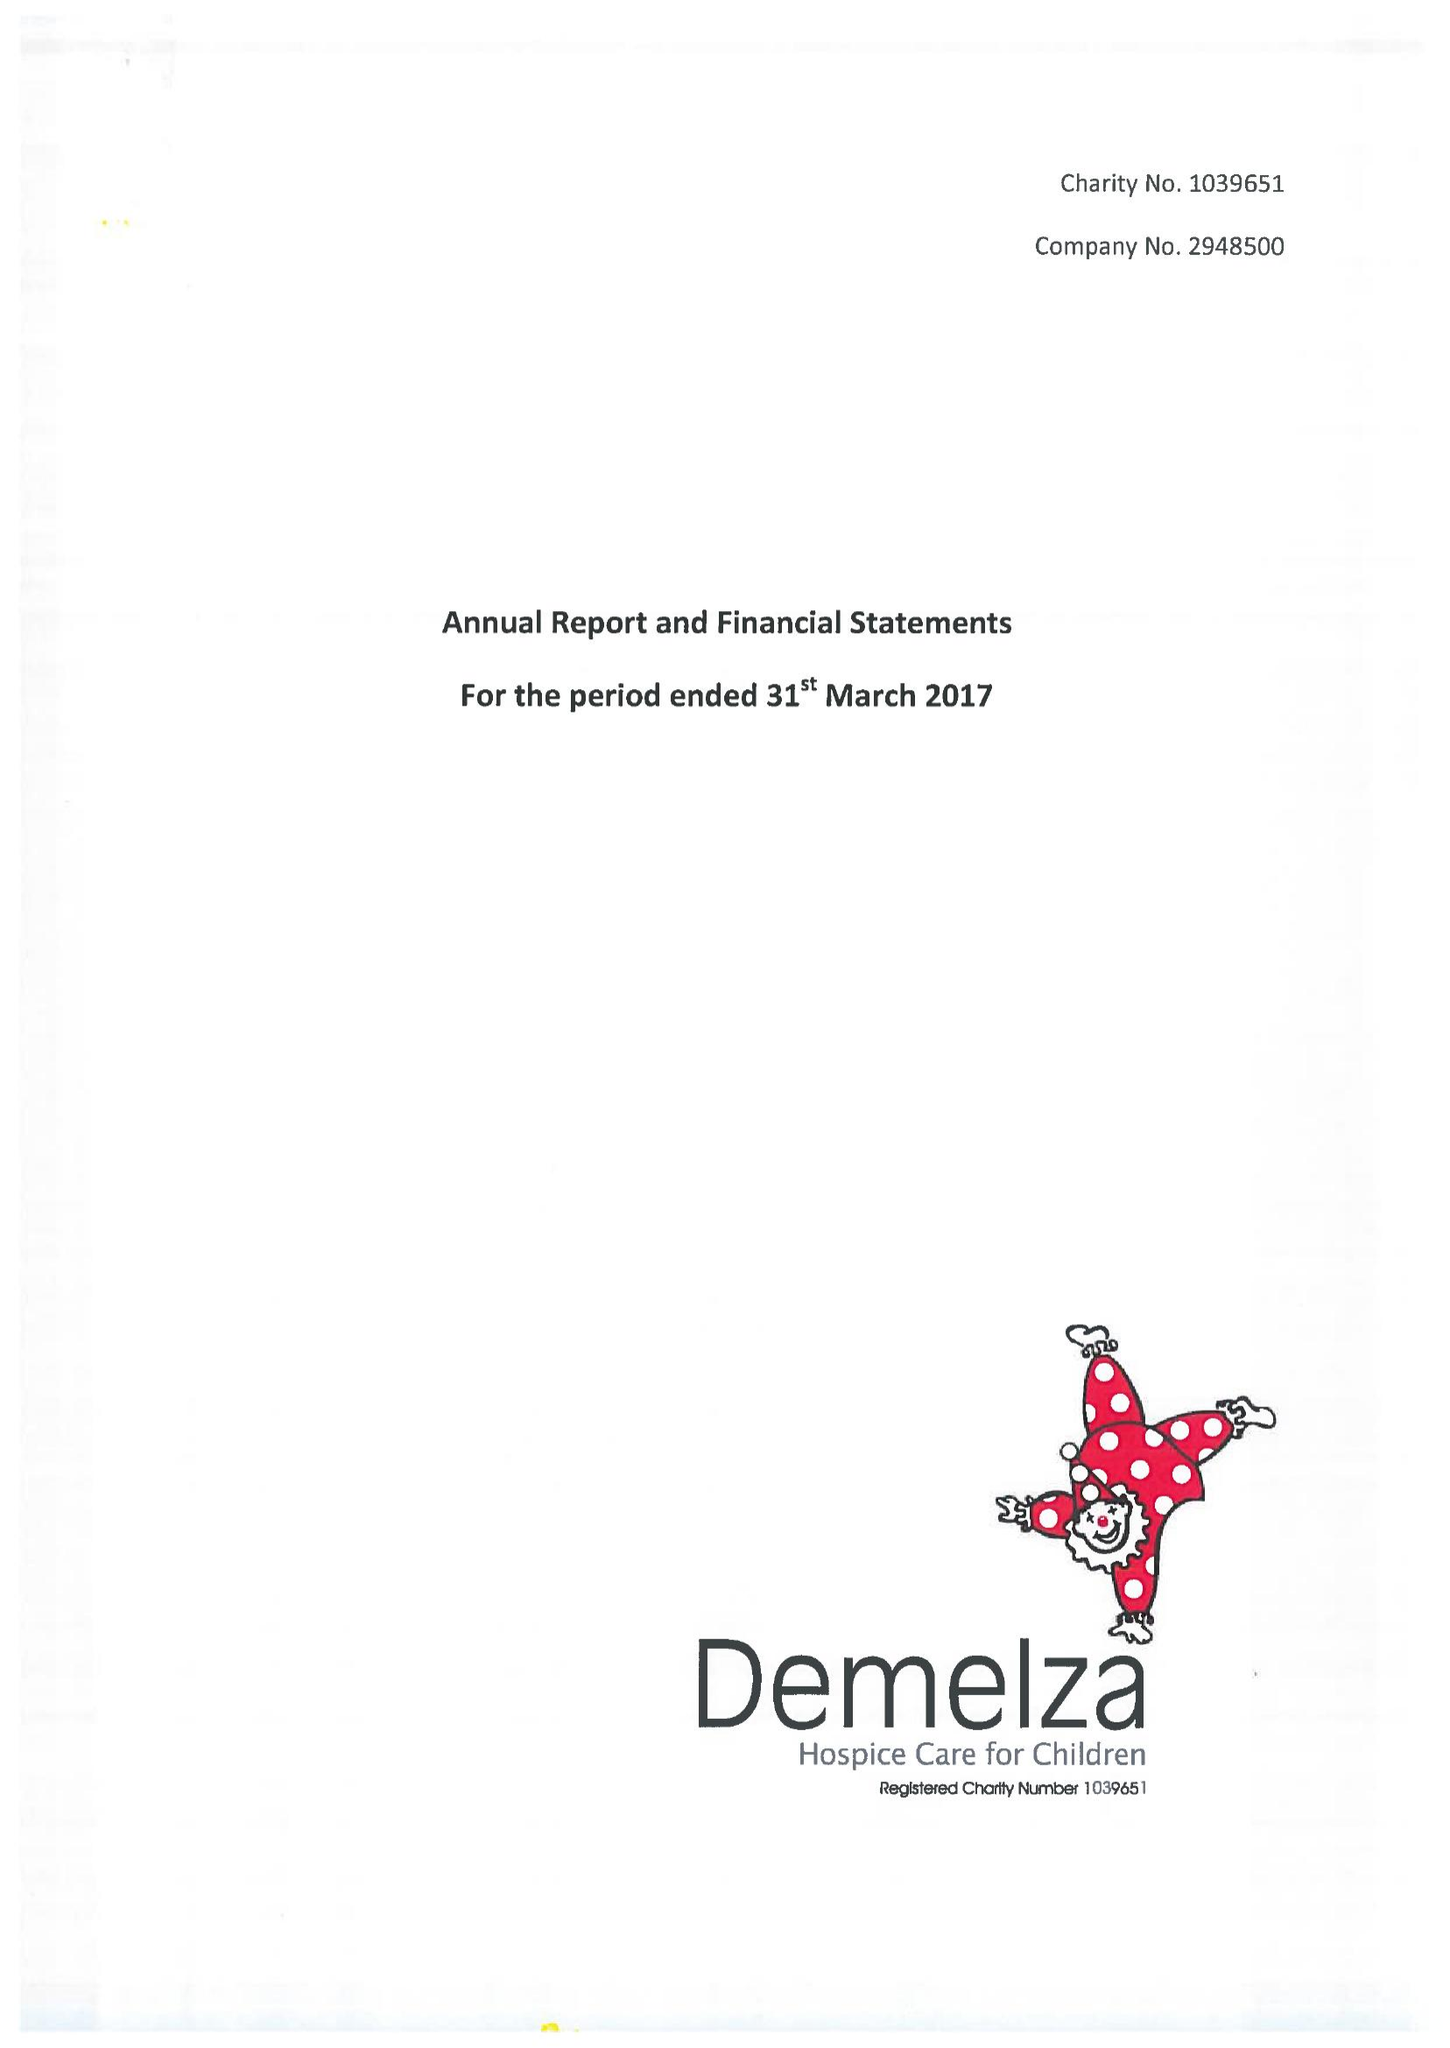What is the value for the income_annually_in_british_pounds?
Answer the question using a single word or phrase. 15648427.00 